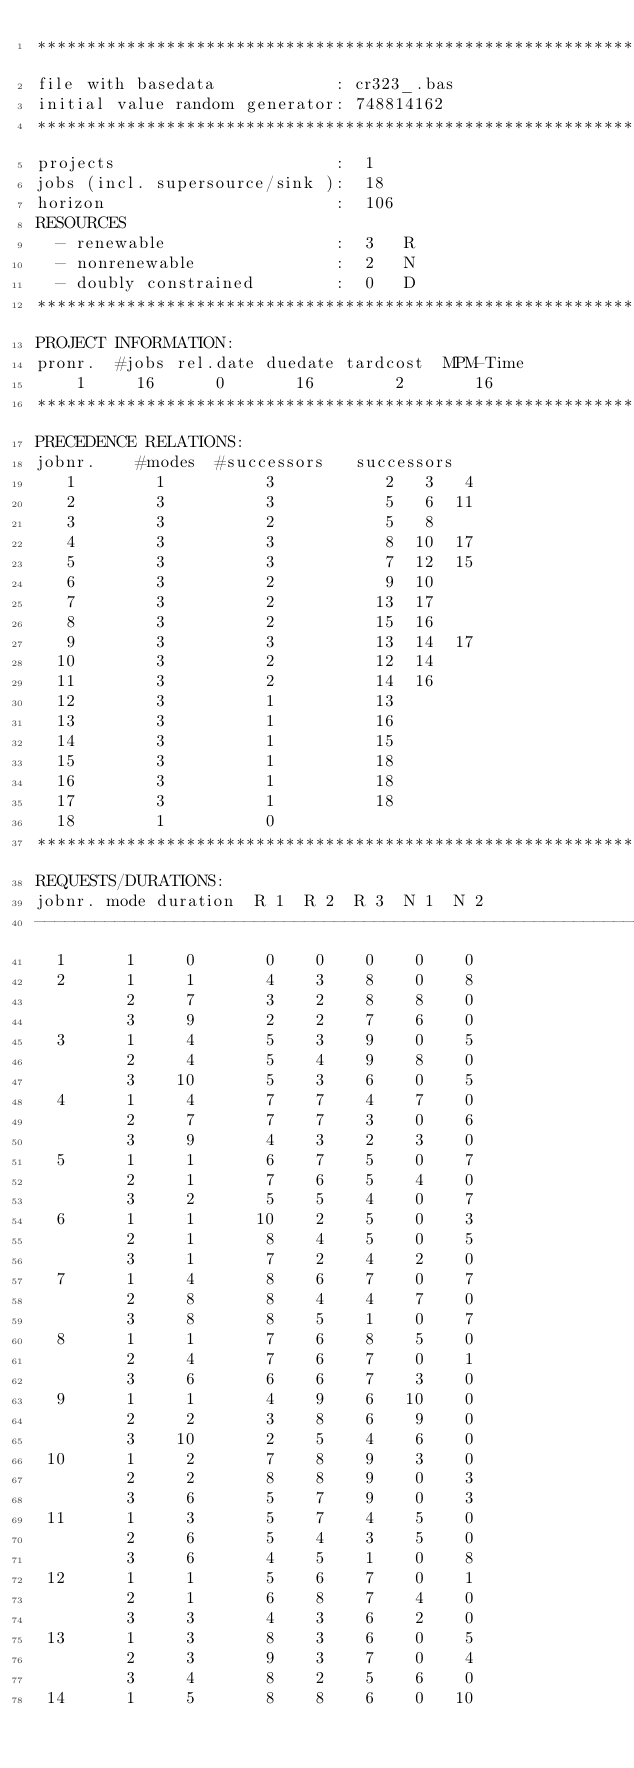<code> <loc_0><loc_0><loc_500><loc_500><_ObjectiveC_>************************************************************************
file with basedata            : cr323_.bas
initial value random generator: 748814162
************************************************************************
projects                      :  1
jobs (incl. supersource/sink ):  18
horizon                       :  106
RESOURCES
  - renewable                 :  3   R
  - nonrenewable              :  2   N
  - doubly constrained        :  0   D
************************************************************************
PROJECT INFORMATION:
pronr.  #jobs rel.date duedate tardcost  MPM-Time
    1     16      0       16        2       16
************************************************************************
PRECEDENCE RELATIONS:
jobnr.    #modes  #successors   successors
   1        1          3           2   3   4
   2        3          3           5   6  11
   3        3          2           5   8
   4        3          3           8  10  17
   5        3          3           7  12  15
   6        3          2           9  10
   7        3          2          13  17
   8        3          2          15  16
   9        3          3          13  14  17
  10        3          2          12  14
  11        3          2          14  16
  12        3          1          13
  13        3          1          16
  14        3          1          15
  15        3          1          18
  16        3          1          18
  17        3          1          18
  18        1          0        
************************************************************************
REQUESTS/DURATIONS:
jobnr. mode duration  R 1  R 2  R 3  N 1  N 2
------------------------------------------------------------------------
  1      1     0       0    0    0    0    0
  2      1     1       4    3    8    0    8
         2     7       3    2    8    8    0
         3     9       2    2    7    6    0
  3      1     4       5    3    9    0    5
         2     4       5    4    9    8    0
         3    10       5    3    6    0    5
  4      1     4       7    7    4    7    0
         2     7       7    7    3    0    6
         3     9       4    3    2    3    0
  5      1     1       6    7    5    0    7
         2     1       7    6    5    4    0
         3     2       5    5    4    0    7
  6      1     1      10    2    5    0    3
         2     1       8    4    5    0    5
         3     1       7    2    4    2    0
  7      1     4       8    6    7    0    7
         2     8       8    4    4    7    0
         3     8       8    5    1    0    7
  8      1     1       7    6    8    5    0
         2     4       7    6    7    0    1
         3     6       6    6    7    3    0
  9      1     1       4    9    6   10    0
         2     2       3    8    6    9    0
         3    10       2    5    4    6    0
 10      1     2       7    8    9    3    0
         2     2       8    8    9    0    3
         3     6       5    7    9    0    3
 11      1     3       5    7    4    5    0
         2     6       5    4    3    5    0
         3     6       4    5    1    0    8
 12      1     1       5    6    7    0    1
         2     1       6    8    7    4    0
         3     3       4    3    6    2    0
 13      1     3       8    3    6    0    5
         2     3       9    3    7    0    4
         3     4       8    2    5    6    0
 14      1     5       8    8    6    0   10</code> 